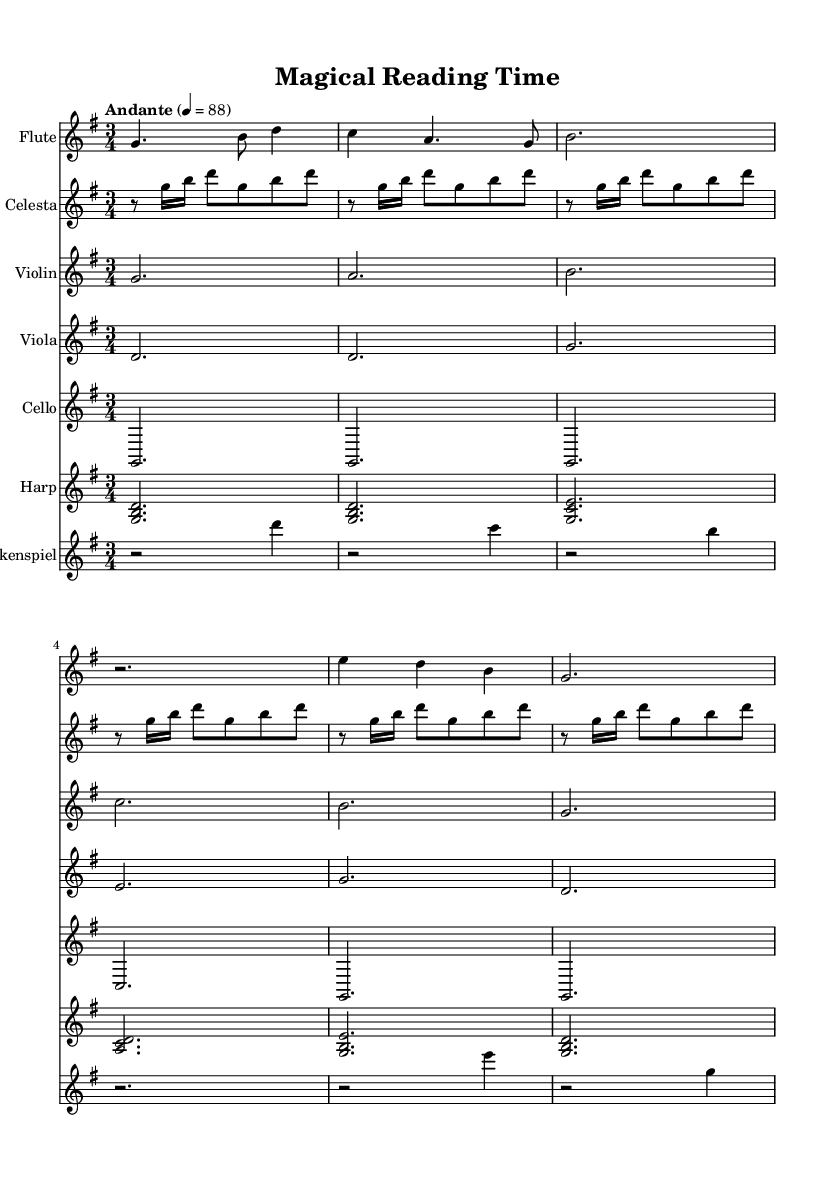What is the key signature of this music? The key signature is G major, which contains one sharp (F#). This can be identified by looking at the key signature at the beginning of the staff.
Answer: G major What is the time signature of this music? The time signature is 3/4, indicated at the beginning of the score, which shows that there are three beats in each measure and a quarter note gets one beat.
Answer: 3/4 What is the tempo marking of this music? The tempo marking is "Andante", appearing at the first line of the score, which suggests a moderate pace. Specifically, it indicates a speed of 88 beats per minute.
Answer: Andante How many measures are present in the flute part? To find the number of measures, we count the individual divisions in the flute part. Each line has a different number of measures, but considering the entire flute part, there are a total of 5 measures.
Answer: 5 Which instruments are included in this orchestration? The orchestration includes flute, celesta, violin, viola, cello, harp, and glockenspiel. This can be identified by reviewing the staff lines listed at the beginning of each instrument's part in the score.
Answer: Flute, celesta, violin, viola, cello, harp, glockenspiel Which instrument plays the opening note in the piece? The first note of the score is played by the flute. This is determined by looking at the very beginning of the flute part, where the first note (G) is written.
Answer: Flute What type of music is represented by this sheet music? This sheet music represents a whimsical orchestral soundtrack, typical of children's fantasy movies. This is evident from the instrumentation and the overall playful and light-hearted style suggested by the notes and rhythms.
Answer: Whimsical orchestral soundtrack 